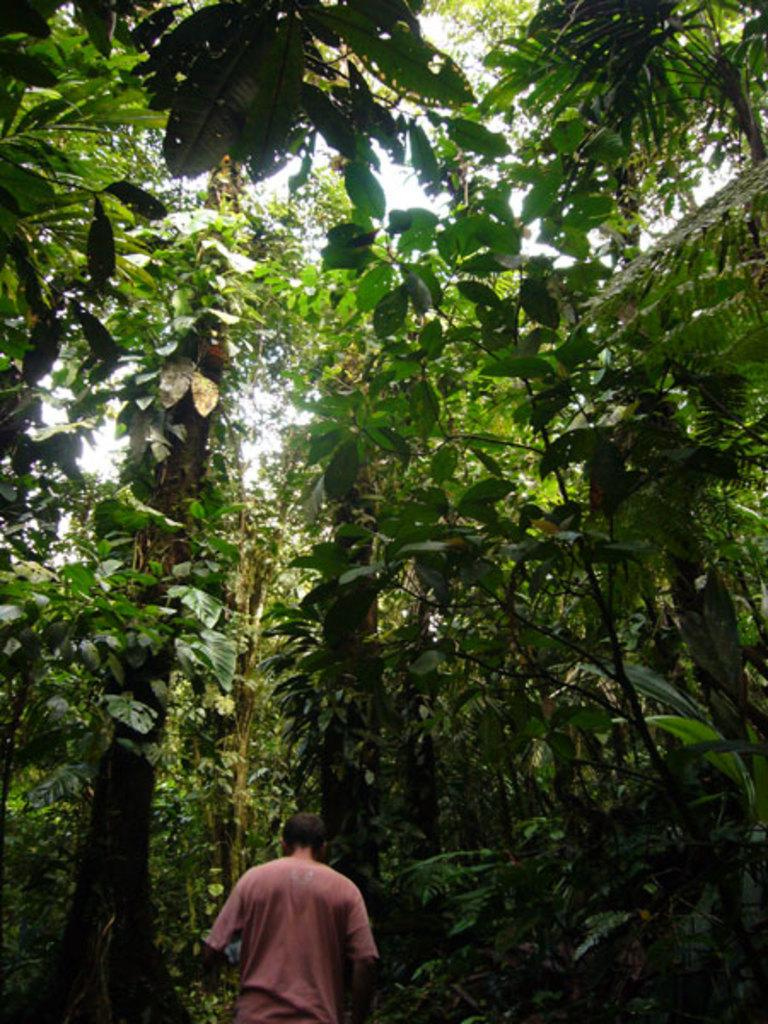What type of vegetation can be seen in the image? There are green color trees in the image. What is the person in the image doing? A person is walking in the image. Are there any actors performing in the plantation depicted in the image? There is no plantation or actors present in the image; it features green color trees and a person walking. Were there any slaves working in the plantation depicted in the image? There is no plantation or reference to slaves in the image; it features green color trees and a person walking. 